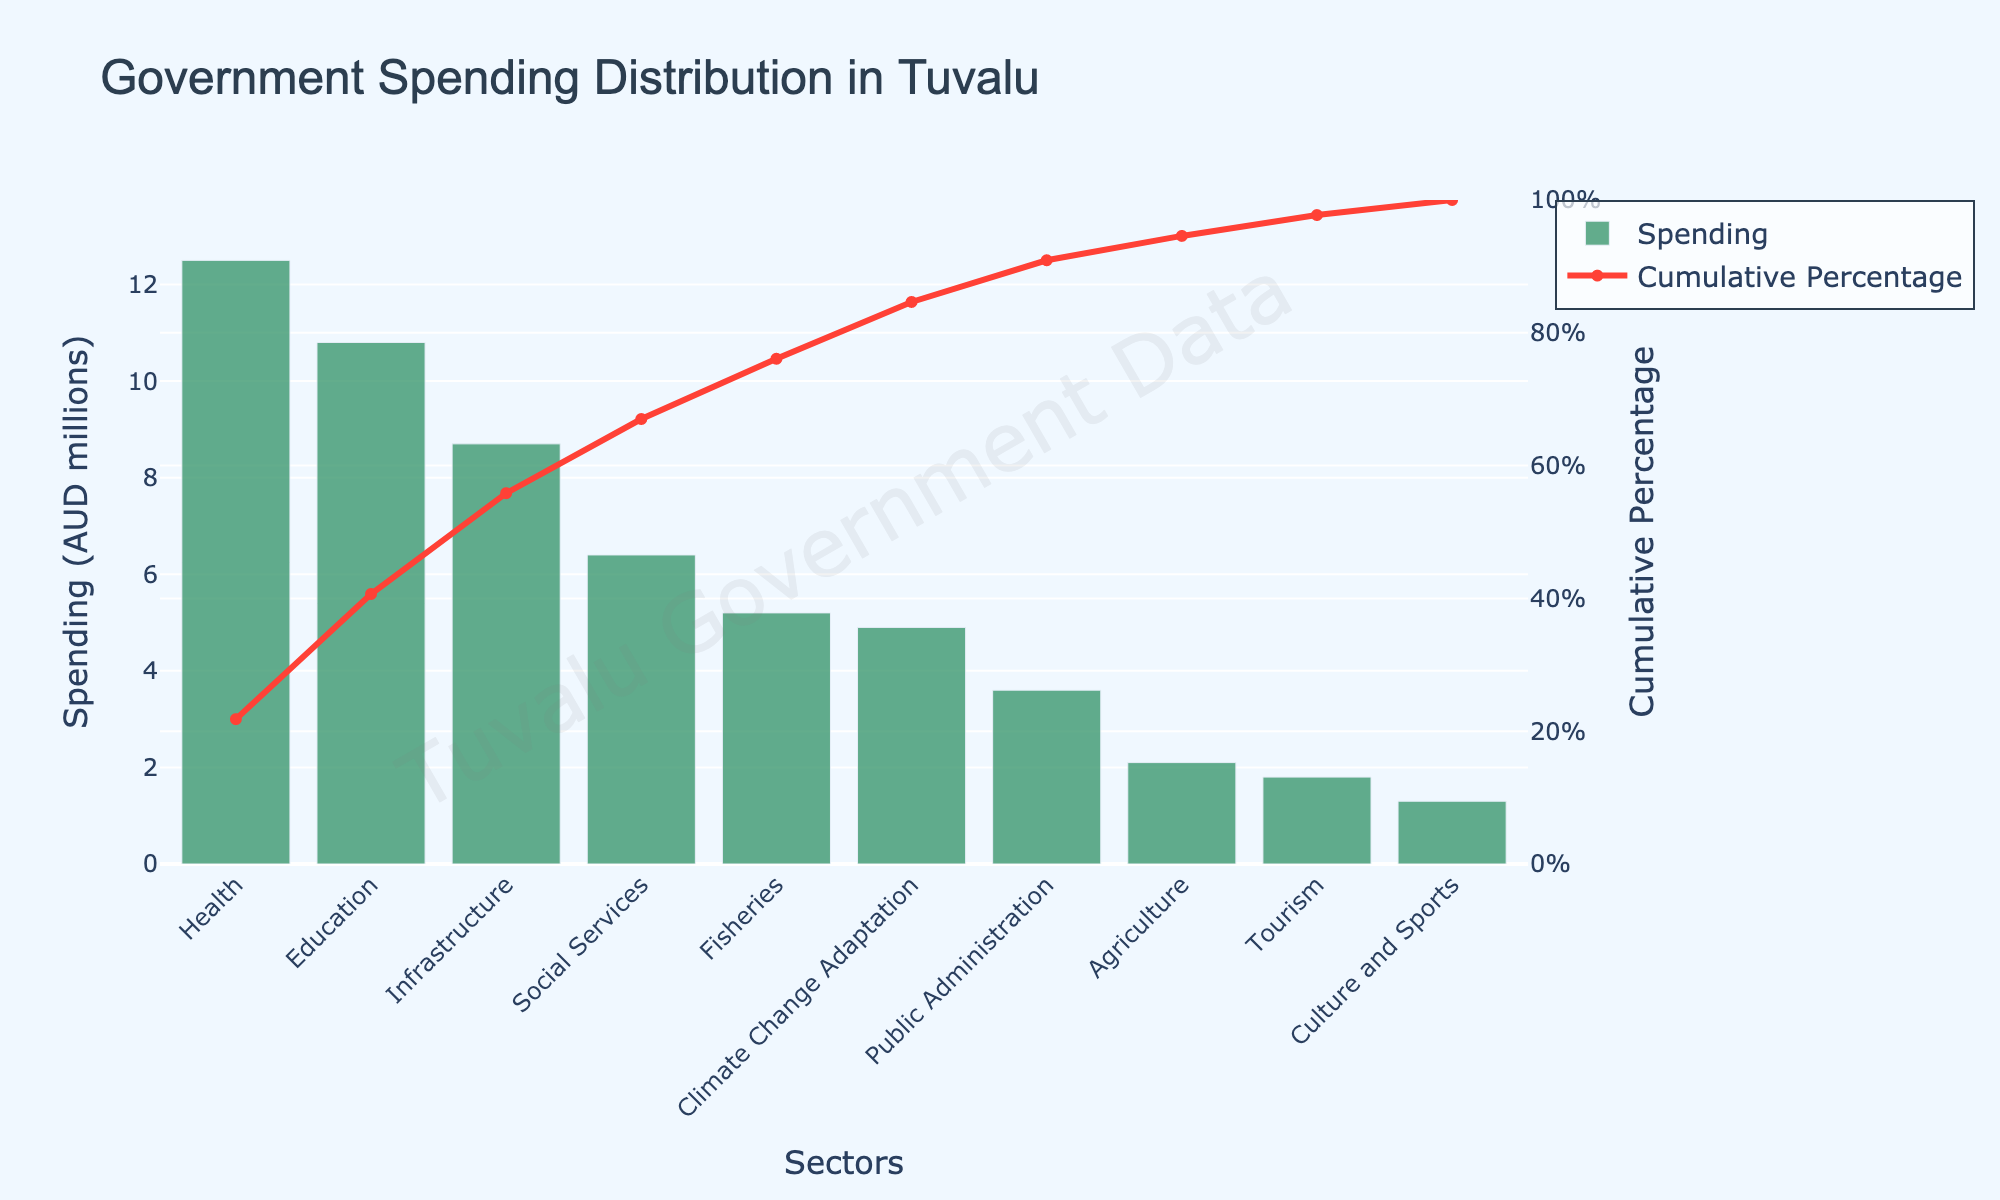What is the title of the figure? The title is displayed at the top of the figure. It is indicated in a larger font size.
Answer: Government Spending Distribution in Tuvalu Which sector has the highest government spending? The sector with the highest bar in the bar chart represents the sector with the highest government spending.
Answer: Health How much does the Tuvalu government spend on education? Look for the bar labeled "Education" on the x-axis and check the height of the bar on the y-axis.
Answer: 10.8 million AUD Which sector shows the smallest amount of government spending? The sector with the smallest bar in the bar chart represents the sector with the smallest government spending.
Answer: Culture and Sports What is the cumulative percentage for the Education sector? Find the "Education" sector on the x-axis and trace it to the corresponding point in the cumulative percentage line chart.
Answer: Around 39% How much more does the government spend on Health compared to Agriculture? Subtract the spending on Agriculture from the spending on Health.
Answer: 10.4 million AUD What is the total government spending covered by the top 3 sectors? Sum the spending amounts for the top three sectors: Health, Education, and Infrastructure.
Answer: 32.0 million AUD Between which sectors does the cumulative percentage first exceed 50%? Look at the cumulative percentage line chart and identify the point where it first crosses 50%. Check the sectors before and after this point on the x-axis.
Answer: Between Infrastructure and Social Services What is the cumulative percentage after the top 5 sectors? Find the fifth sector on the x-axis and trace it to the corresponding point in the cumulative percentage line chart.
Answer: Around 76.2% Which sectors together account for nearly 80% of the total government spending? Look at the cumulative percentage line chart to find the point close to 80%. Identify all sectors up to that point on the x-axis.
Answer: Health, Education, Infrastructure, Social Services, Fisheries, Climate Change Adaptation 